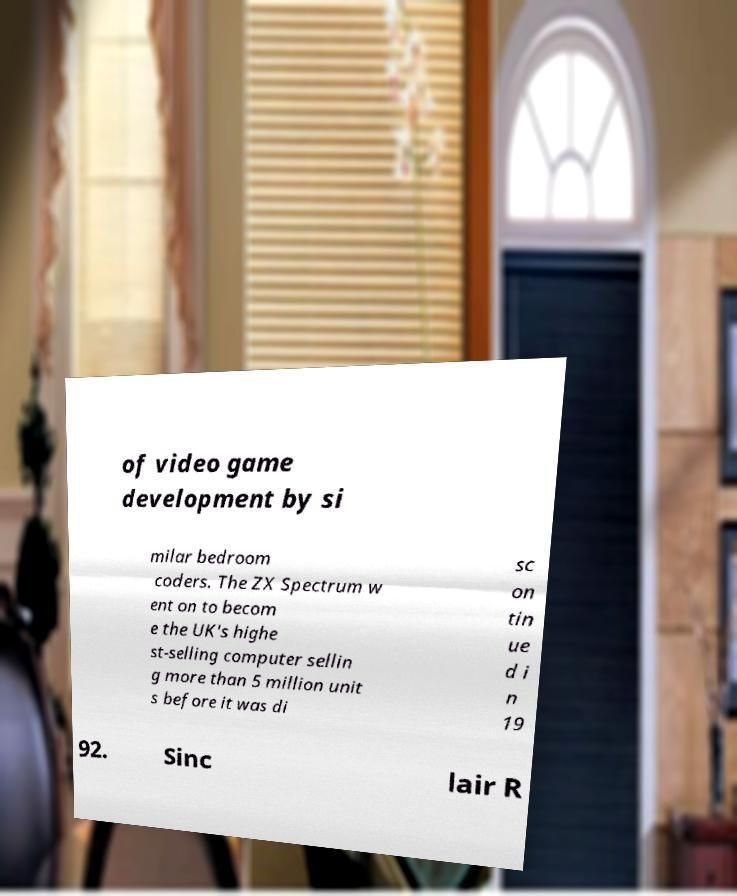What messages or text are displayed in this image? I need them in a readable, typed format. of video game development by si milar bedroom coders. The ZX Spectrum w ent on to becom e the UK's highe st-selling computer sellin g more than 5 million unit s before it was di sc on tin ue d i n 19 92. Sinc lair R 